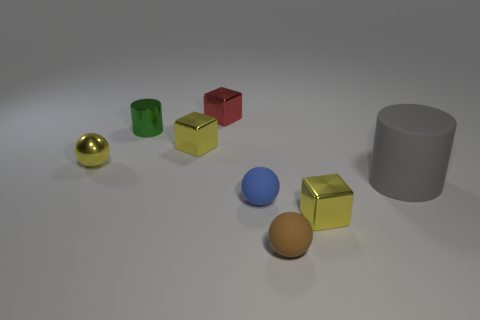Add 2 tiny green rubber cylinders. How many objects exist? 10 Subtract all small yellow cubes. How many cubes are left? 1 Subtract all small purple metallic balls. Subtract all metallic cylinders. How many objects are left? 7 Add 5 small matte balls. How many small matte balls are left? 7 Add 2 brown matte things. How many brown matte things exist? 3 Subtract all yellow cubes. How many cubes are left? 1 Subtract 1 green cylinders. How many objects are left? 7 Subtract all spheres. How many objects are left? 5 Subtract 1 cylinders. How many cylinders are left? 1 Subtract all yellow cylinders. Subtract all green blocks. How many cylinders are left? 2 